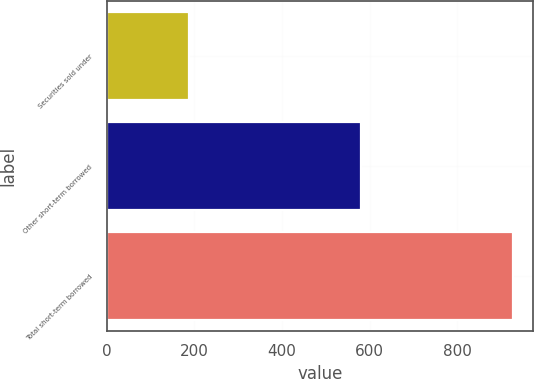Convert chart to OTSL. <chart><loc_0><loc_0><loc_500><loc_500><bar_chart><fcel>Securities sold under<fcel>Other short-term borrowed<fcel>Total short-term borrowed<nl><fcel>187<fcel>581<fcel>927<nl></chart> 